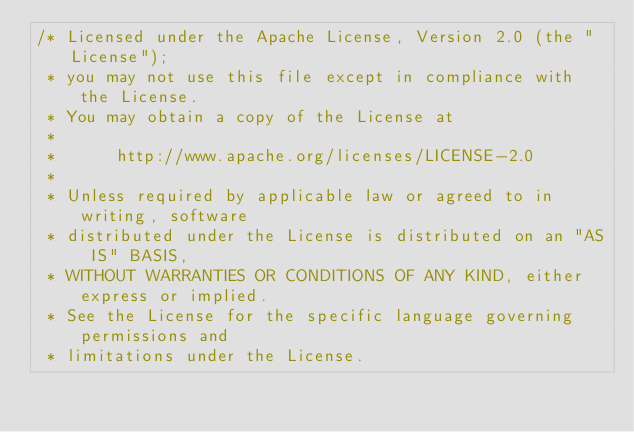Convert code to text. <code><loc_0><loc_0><loc_500><loc_500><_Java_>/* Licensed under the Apache License, Version 2.0 (the "License");
 * you may not use this file except in compliance with the License.
 * You may obtain a copy of the License at
 * 
 *      http://www.apache.org/licenses/LICENSE-2.0
 * 
 * Unless required by applicable law or agreed to in writing, software
 * distributed under the License is distributed on an "AS IS" BASIS,
 * WITHOUT WARRANTIES OR CONDITIONS OF ANY KIND, either express or implied.
 * See the License for the specific language governing permissions and
 * limitations under the License.</code> 